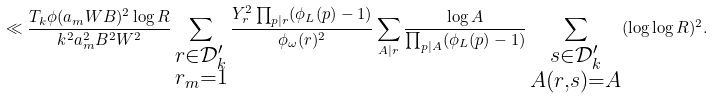<formula> <loc_0><loc_0><loc_500><loc_500>\ll \frac { T _ { k } \phi ( a _ { m } W B ) ^ { 2 } \log { R } } { k ^ { 2 } a _ { m } ^ { 2 } B ^ { 2 } W ^ { 2 } } \sum _ { \substack { r \in \mathcal { D } ^ { \prime } _ { k } \\ r _ { m } = 1 } } \frac { Y _ { r } ^ { 2 } \prod _ { p | r } ( \phi _ { L } ( p ) - 1 ) } { \phi _ { \omega } ( r ) ^ { 2 } } \sum _ { A | r } \frac { \log { A } } { \prod _ { p | A } ( \phi _ { L } ( p ) - 1 ) } \sum _ { \substack { s \in \mathcal { D } ^ { \prime } _ { k } \\ A ( r , s ) = A } } ( \log \log { R } ) ^ { 2 } .</formula> 